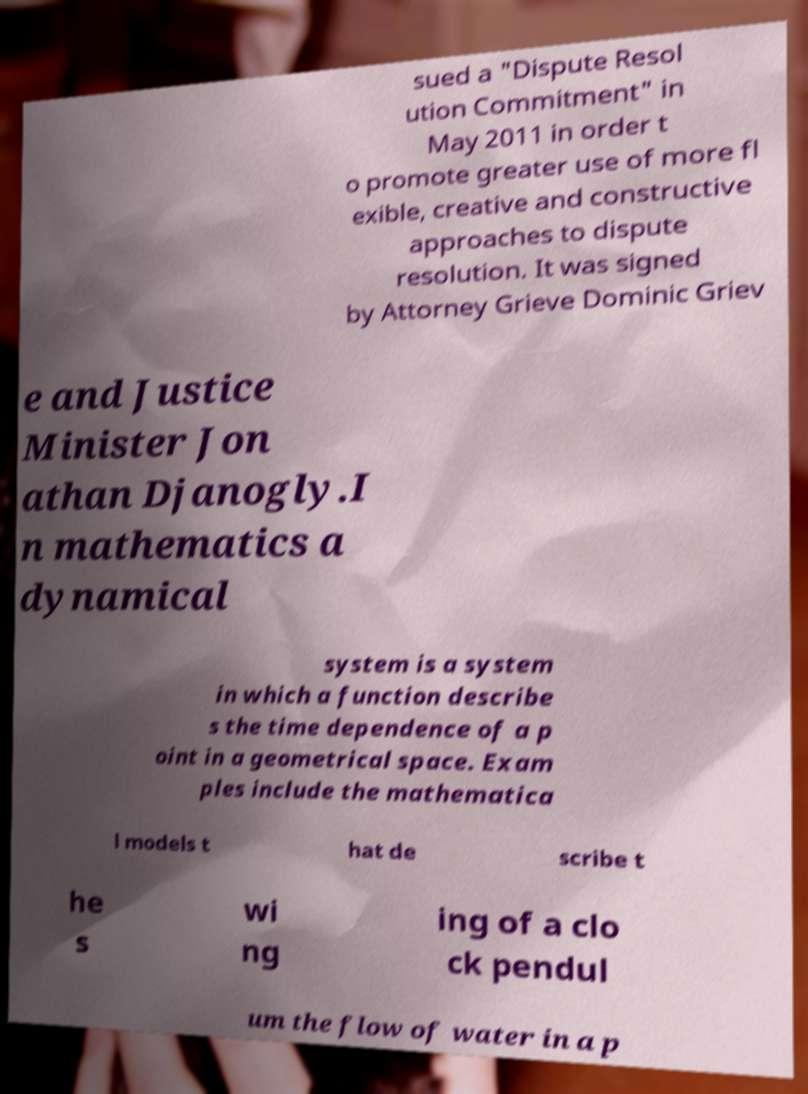I need the written content from this picture converted into text. Can you do that? sued a "Dispute Resol ution Commitment" in May 2011 in order t o promote greater use of more fl exible, creative and constructive approaches to dispute resolution. It was signed by Attorney Grieve Dominic Griev e and Justice Minister Jon athan Djanogly.I n mathematics a dynamical system is a system in which a function describe s the time dependence of a p oint in a geometrical space. Exam ples include the mathematica l models t hat de scribe t he s wi ng ing of a clo ck pendul um the flow of water in a p 